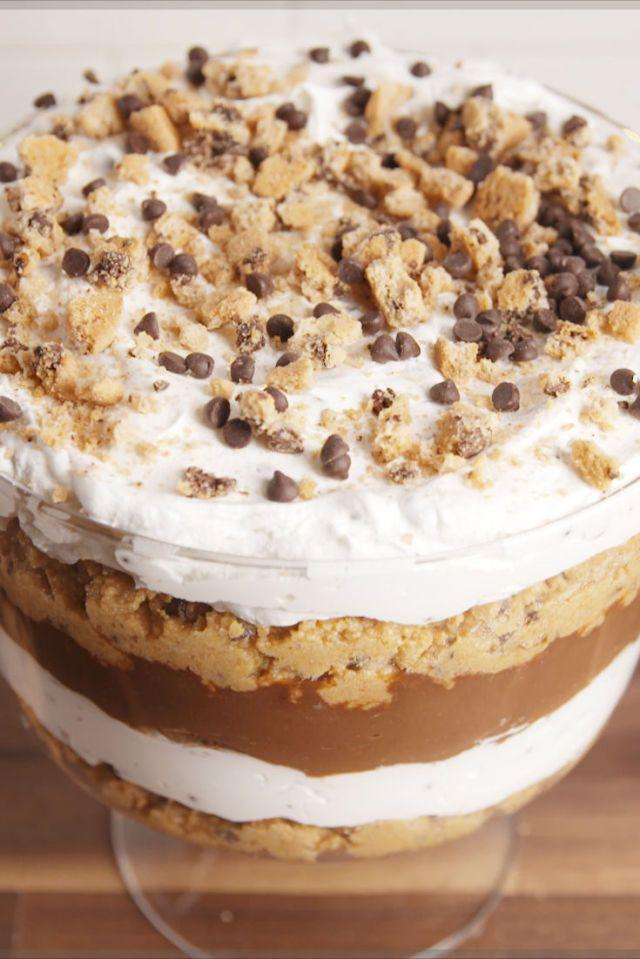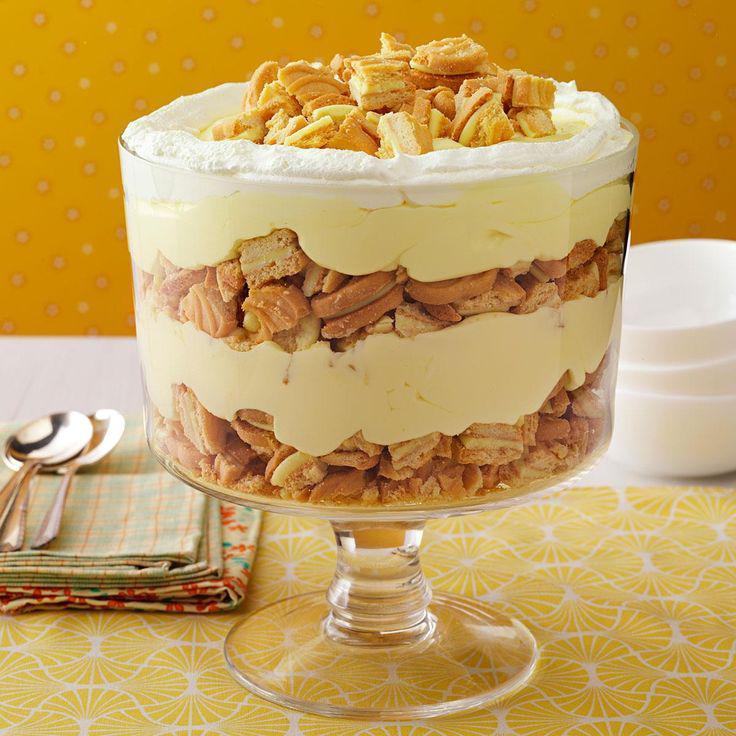The first image is the image on the left, the second image is the image on the right. Given the left and right images, does the statement "An image of a layered dessert in a clear glass includes lemon in the scene." hold true? Answer yes or no. No. The first image is the image on the left, the second image is the image on the right. Given the left and right images, does the statement "Two large multi-layered desserts have been prepared in clear glass footed bowls" hold true? Answer yes or no. Yes. 